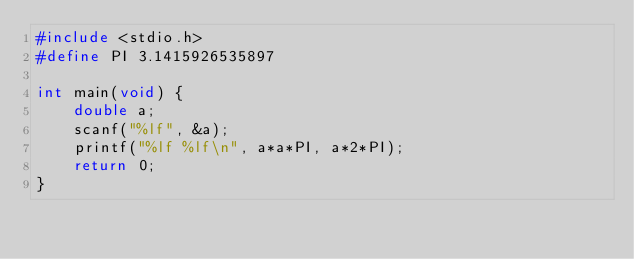Convert code to text. <code><loc_0><loc_0><loc_500><loc_500><_C_>#include <stdio.h>
#define PI 3.1415926535897

int main(void) {
	double a;
	scanf("%lf", &a);
	printf("%lf %lf\n", a*a*PI, a*2*PI);
	return 0;
}</code> 